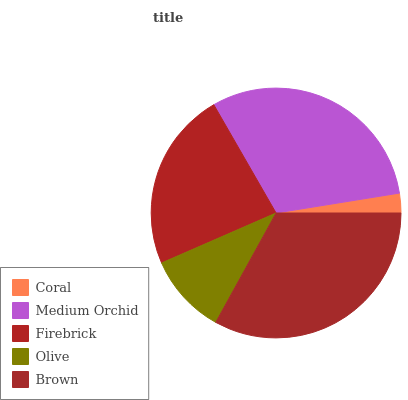Is Coral the minimum?
Answer yes or no. Yes. Is Brown the maximum?
Answer yes or no. Yes. Is Medium Orchid the minimum?
Answer yes or no. No. Is Medium Orchid the maximum?
Answer yes or no. No. Is Medium Orchid greater than Coral?
Answer yes or no. Yes. Is Coral less than Medium Orchid?
Answer yes or no. Yes. Is Coral greater than Medium Orchid?
Answer yes or no. No. Is Medium Orchid less than Coral?
Answer yes or no. No. Is Firebrick the high median?
Answer yes or no. Yes. Is Firebrick the low median?
Answer yes or no. Yes. Is Coral the high median?
Answer yes or no. No. Is Medium Orchid the low median?
Answer yes or no. No. 